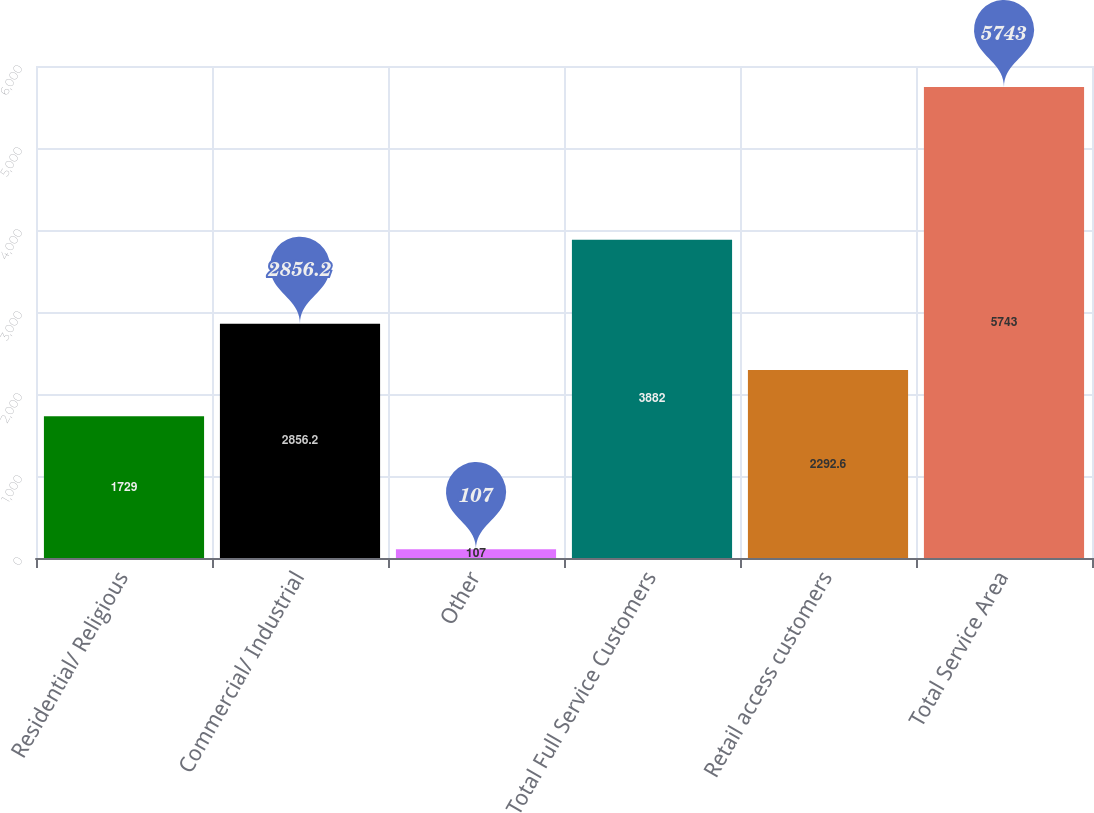Convert chart to OTSL. <chart><loc_0><loc_0><loc_500><loc_500><bar_chart><fcel>Residential/ Religious<fcel>Commercial/ Industrial<fcel>Other<fcel>Total Full Service Customers<fcel>Retail access customers<fcel>Total Service Area<nl><fcel>1729<fcel>2856.2<fcel>107<fcel>3882<fcel>2292.6<fcel>5743<nl></chart> 